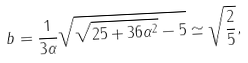<formula> <loc_0><loc_0><loc_500><loc_500>b = \frac { 1 } { 3 \alpha } \sqrt { \sqrt { 2 5 + 3 6 \alpha ^ { 2 } } - 5 } \simeq \sqrt { \frac { 2 } { 5 } } ,</formula> 